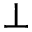Convert formula to latex. <formula><loc_0><loc_0><loc_500><loc_500>\perp</formula> 